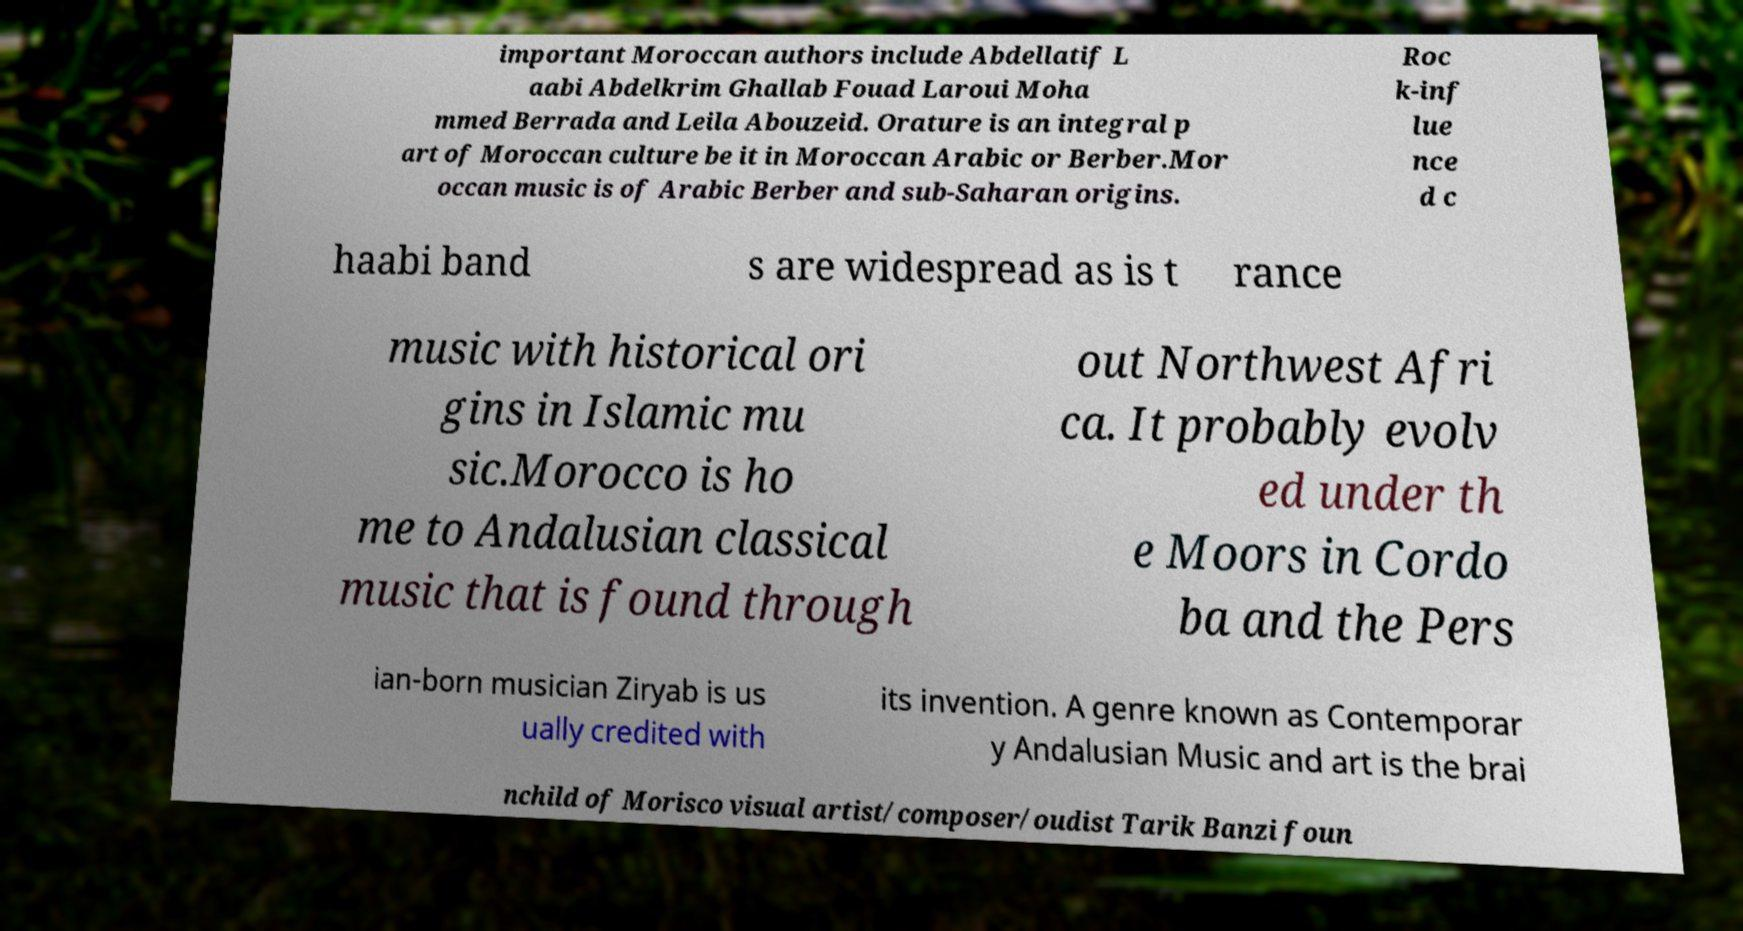Could you extract and type out the text from this image? important Moroccan authors include Abdellatif L aabi Abdelkrim Ghallab Fouad Laroui Moha mmed Berrada and Leila Abouzeid. Orature is an integral p art of Moroccan culture be it in Moroccan Arabic or Berber.Mor occan music is of Arabic Berber and sub-Saharan origins. Roc k-inf lue nce d c haabi band s are widespread as is t rance music with historical ori gins in Islamic mu sic.Morocco is ho me to Andalusian classical music that is found through out Northwest Afri ca. It probably evolv ed under th e Moors in Cordo ba and the Pers ian-born musician Ziryab is us ually credited with its invention. A genre known as Contemporar y Andalusian Music and art is the brai nchild of Morisco visual artist/composer/oudist Tarik Banzi foun 